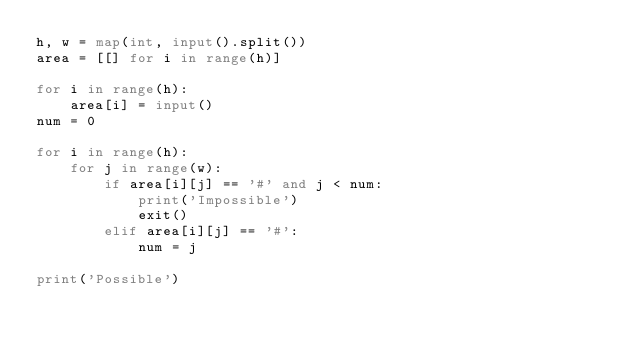<code> <loc_0><loc_0><loc_500><loc_500><_Python_>h, w = map(int, input().split())
area = [[] for i in range(h)]

for i in range(h):
    area[i] = input()
num = 0

for i in range(h):
    for j in range(w):
        if area[i][j] == '#' and j < num:
            print('Impossible')
            exit()
        elif area[i][j] == '#':
            num = j

print('Possible')
</code> 